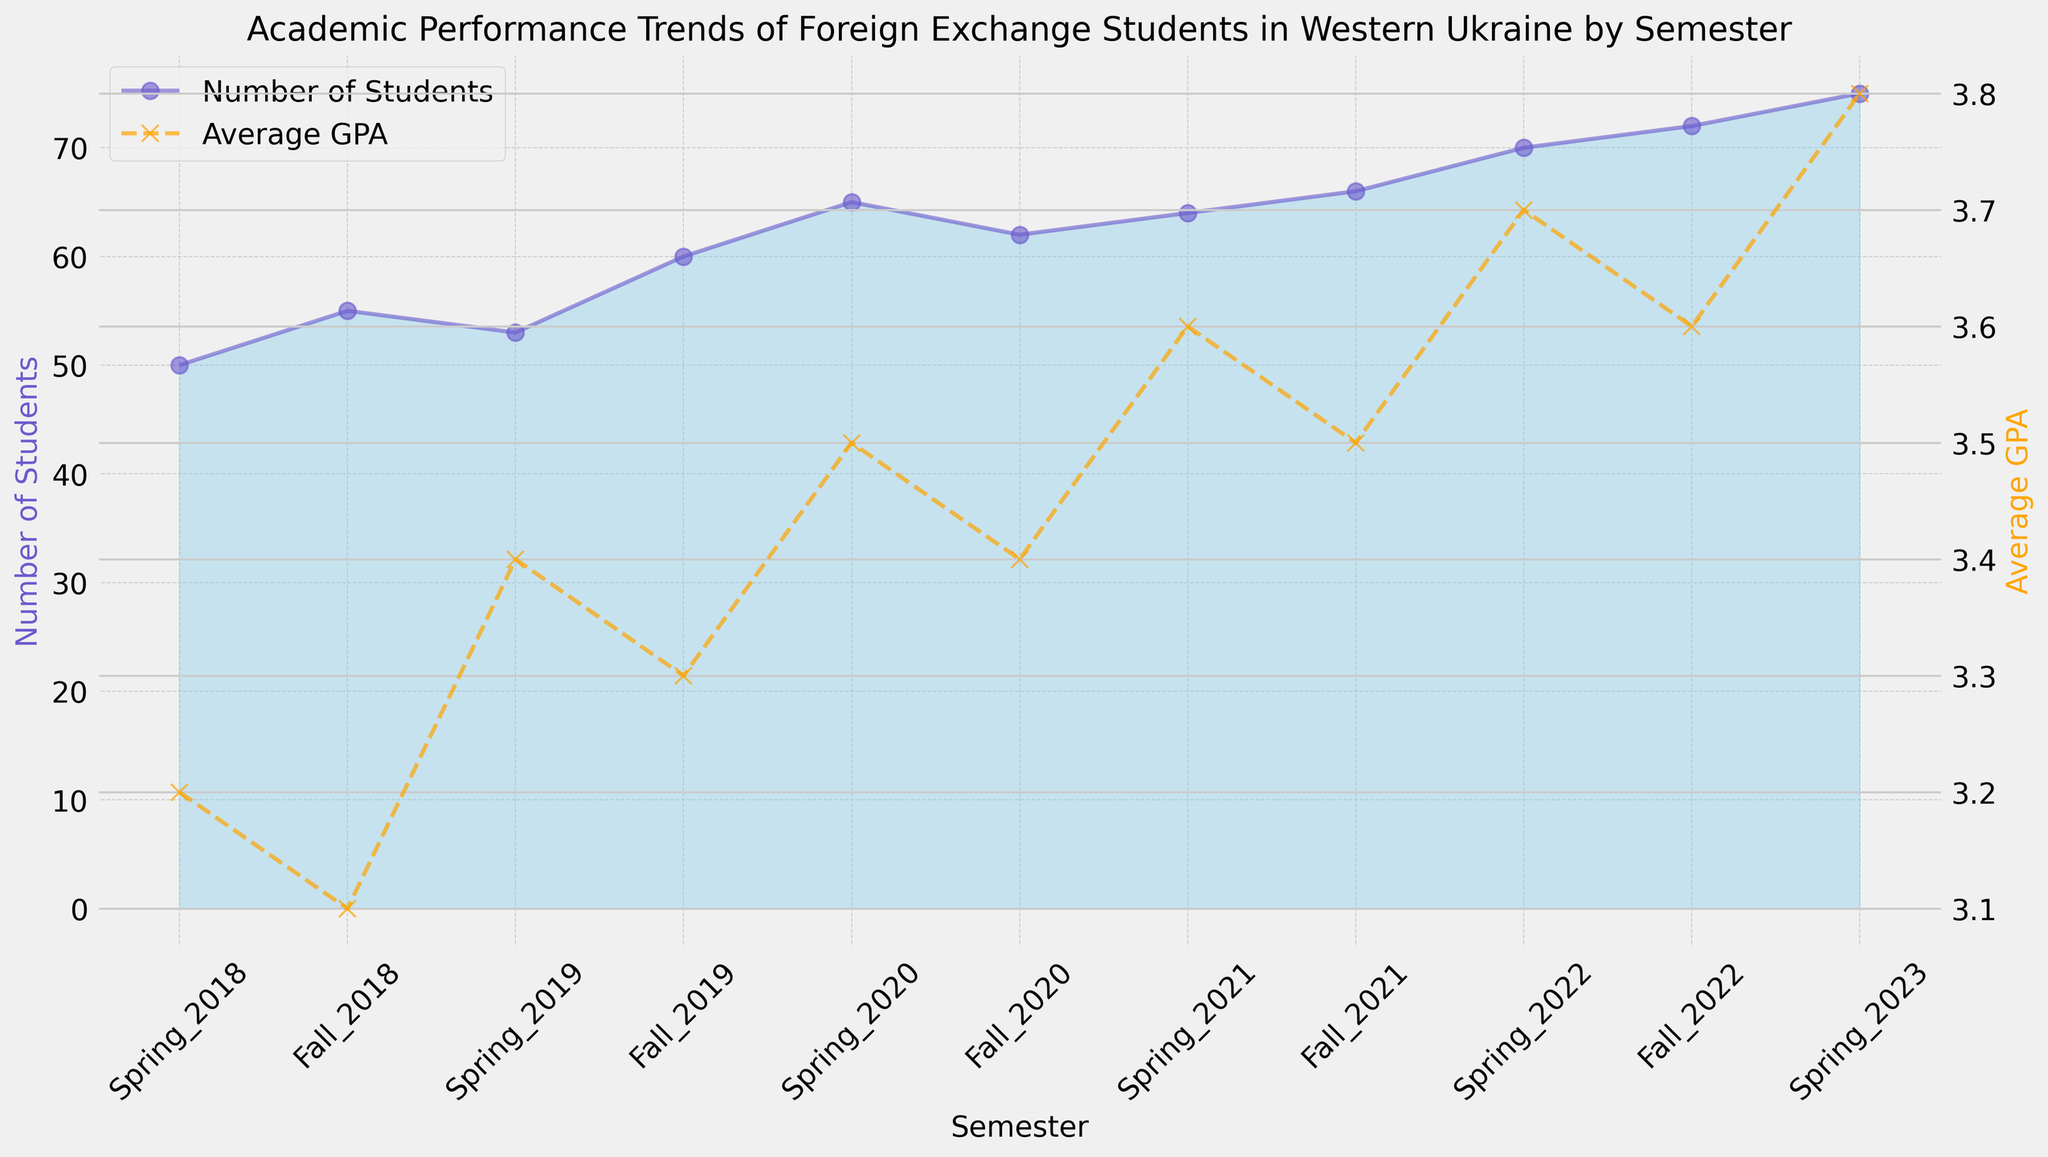What semester had the highest number of students? From the chart, identify the semester where the blue area reaches its peak. The highest point in the number of students occurs in Spring 2023.
Answer: Spring 2023 What is the average GPA for Fall 2020? Observe the orange dashed line representing Average GPA for Fall 2020. The line intersects the y-axis at the point corresponding to 3.4.
Answer: 3.4 Which semester showed the largest increase in the number of students compared to the previous semester? Compare the height of the blue areas between consecutive semesters. The largest increase is noticed between Spring 2019 and Fall 2019. Increase from 53 to 60 students.
Answer: Fall 2019 What is the trend in the average GPA from Spring 2018 through Spring 2023? Look at the overall direction of the orange dashed line from Spring 2018 to Spring 2023. The GPA consistently increases from 3.2 to 3.8 over the semesters.
Answer: Increasing How many students were there in Spring 2020? Find the height of the blue area in Spring 2020. From the chart, the number of students then was 65.
Answer: 65 Compare the number of students in Spring 2018 and Fall 2018. Which semester had more students and by how much? Look at the heights of the blue areas for both semesters. Spring 2018 had 50 students, and Fall 2018 had 55. The increase is 55 - 50 = 5 students.
Answer: Fall 2018 by 5 What is the difference in average GPA between Fall 2021 and Spring 2022? Find the orange dashed line values for Fall 2021 and Spring 2022. Fall 2021 had an average GPA of 3.5, and Spring 2022 had 3.7. The difference is 3.7 - 3.5 = 0.2.
Answer: 0.2 During which semester did the average GPA first exceed 3.5? Observe where the orange dashed line first crosses above 3.5. It is in Spring 2020.
Answer: Spring 2020 How does the number of students in Fall 2022 compare with the number in Fall 2018? Check the blue areas for both semesters. Fall 2022 had 72 students, and Fall 2018 had 55. By comparison, Fall 2022 had 17 more students.
Answer: Fall 2022 had 17 more 